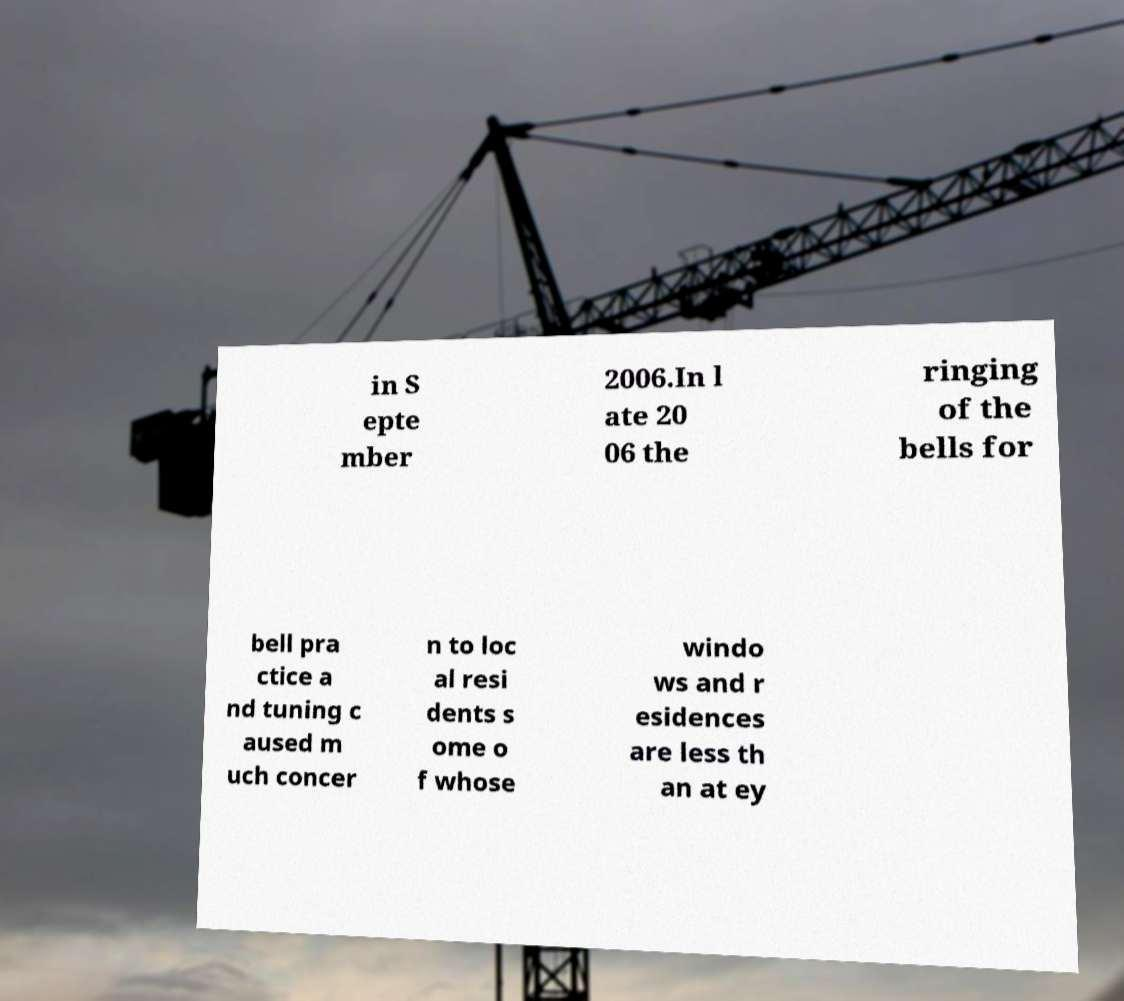For documentation purposes, I need the text within this image transcribed. Could you provide that? in S epte mber 2006.In l ate 20 06 the ringing of the bells for bell pra ctice a nd tuning c aused m uch concer n to loc al resi dents s ome o f whose windo ws and r esidences are less th an at ey 